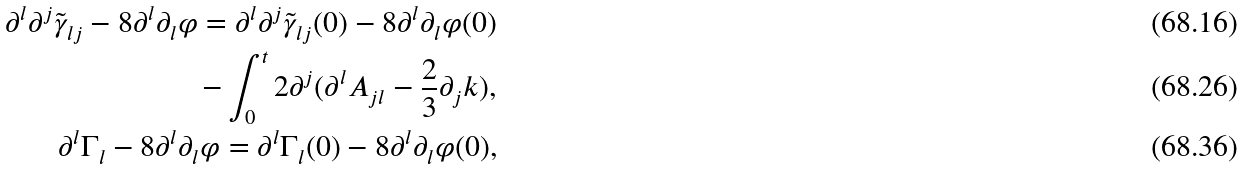<formula> <loc_0><loc_0><loc_500><loc_500>\partial ^ { l } \partial ^ { j } \tilde { \gamma } _ { l j } - 8 \partial ^ { l } \partial _ { l } \varphi = \partial ^ { l } \partial ^ { j } \tilde { \gamma } _ { l j } ( 0 ) - 8 \partial ^ { l } \partial _ { l } \varphi ( 0 ) \\ - \int _ { 0 } ^ { t } 2 \partial ^ { j } ( \partial ^ { l } A _ { j l } - \frac { 2 } { 3 } \partial _ { j } k ) , \\ \partial ^ { l } \Gamma _ { l } - 8 \partial ^ { l } \partial _ { l } \varphi = \partial ^ { l } \Gamma _ { l } ( 0 ) - 8 \partial ^ { l } \partial _ { l } \varphi ( 0 ) ,</formula> 